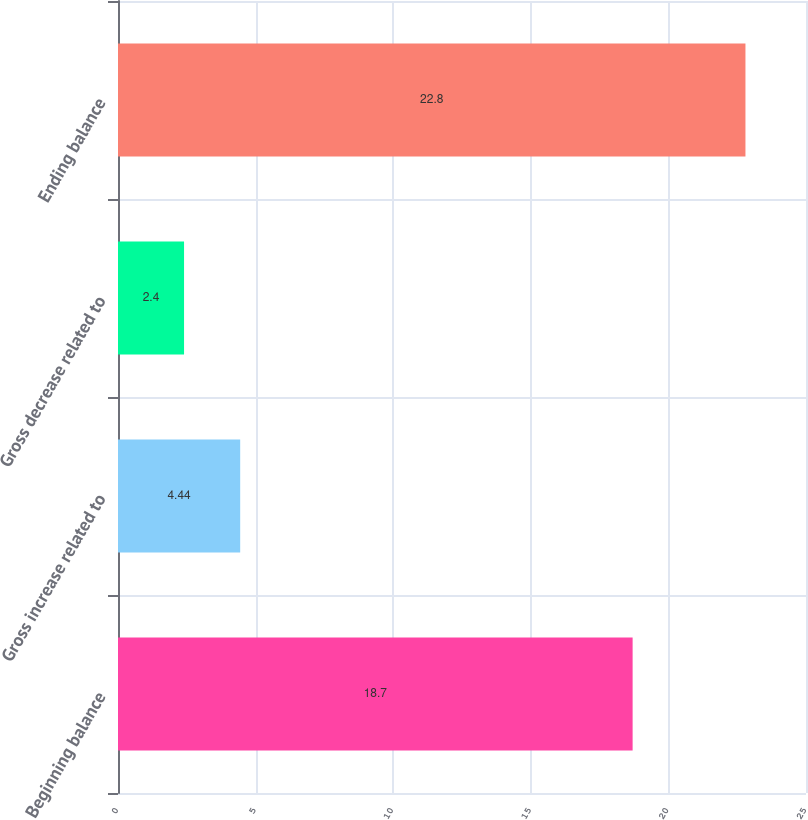<chart> <loc_0><loc_0><loc_500><loc_500><bar_chart><fcel>Beginning balance<fcel>Gross increase related to<fcel>Gross decrease related to<fcel>Ending balance<nl><fcel>18.7<fcel>4.44<fcel>2.4<fcel>22.8<nl></chart> 